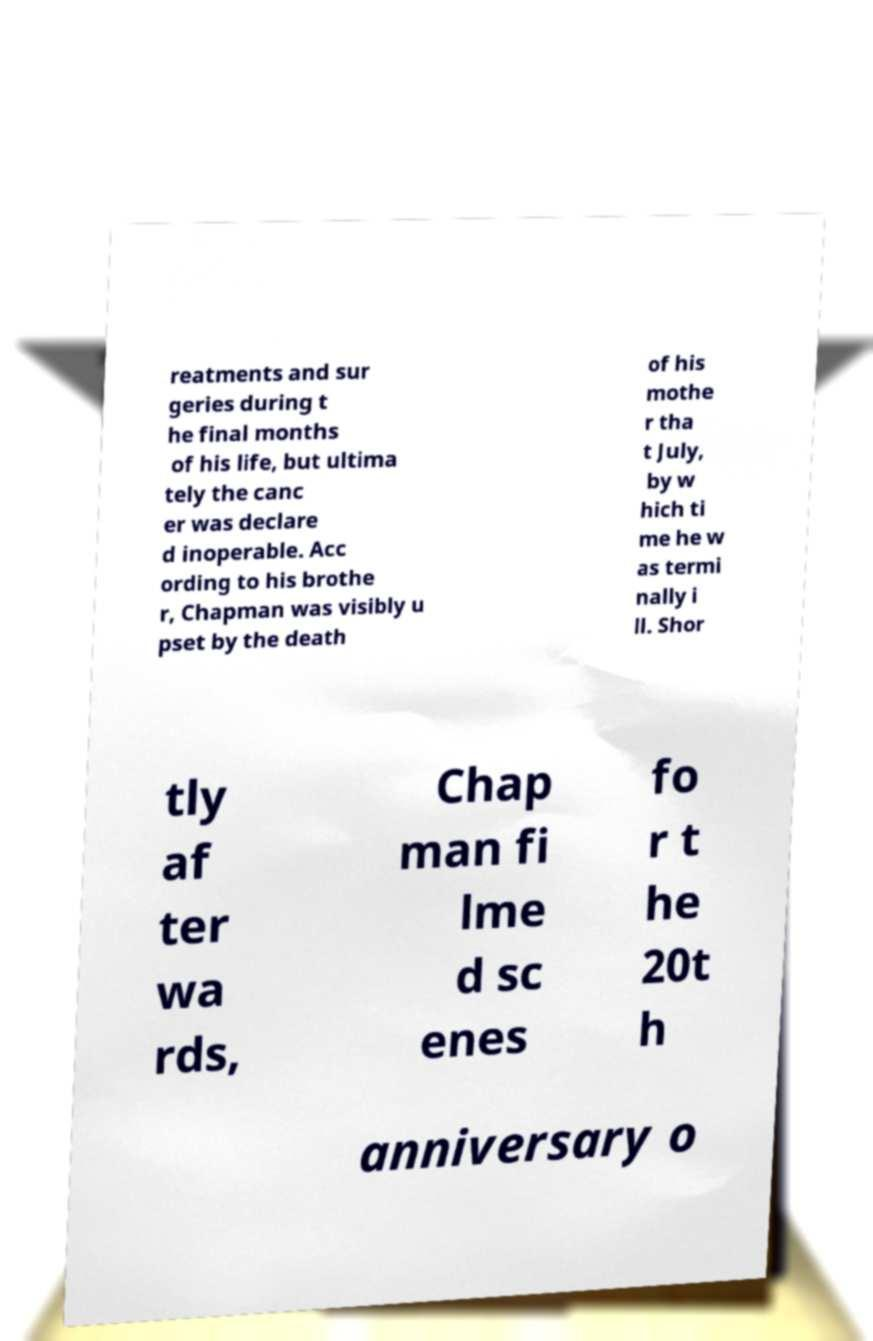Please read and relay the text visible in this image. What does it say? reatments and sur geries during t he final months of his life, but ultima tely the canc er was declare d inoperable. Acc ording to his brothe r, Chapman was visibly u pset by the death of his mothe r tha t July, by w hich ti me he w as termi nally i ll. Shor tly af ter wa rds, Chap man fi lme d sc enes fo r t he 20t h anniversary o 